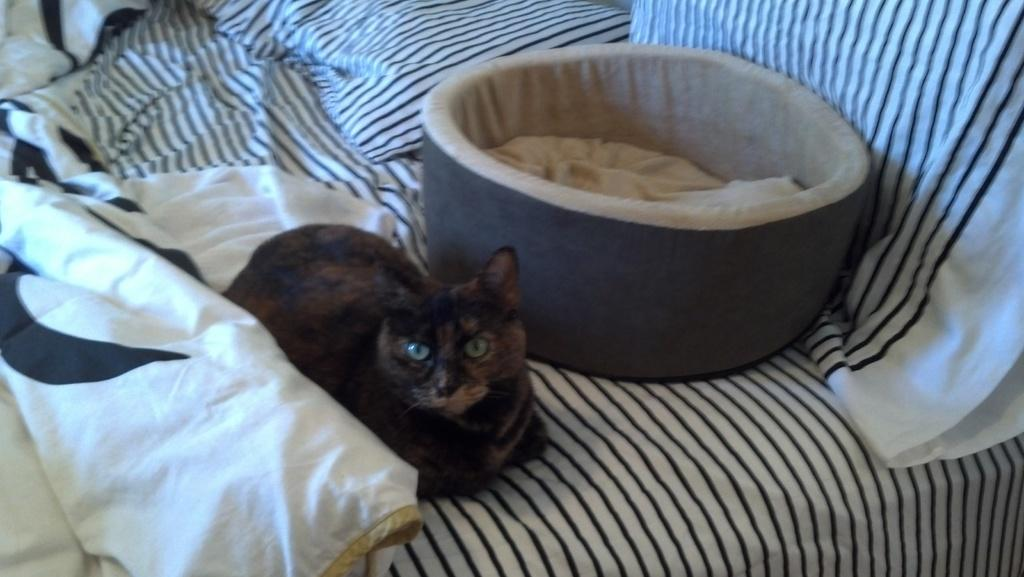What type of furniture is present in the image? A: There is a bed in the image. What is on top of the bed? There is cloth on the bed, and there is a bowl with food on the bed. Where is the bowl with food located in relation to the black-colored cloth? The bowl with food is near the black-colored cloth. Are there any animals visible in the image? Yes, there is a black-colored bird near the bed. What type of hat is the bird wearing in the image? There is no hat present on the bird in the image. What type of pets are visible in the image? There are no pets visible in the image, only a black-colored bird. 